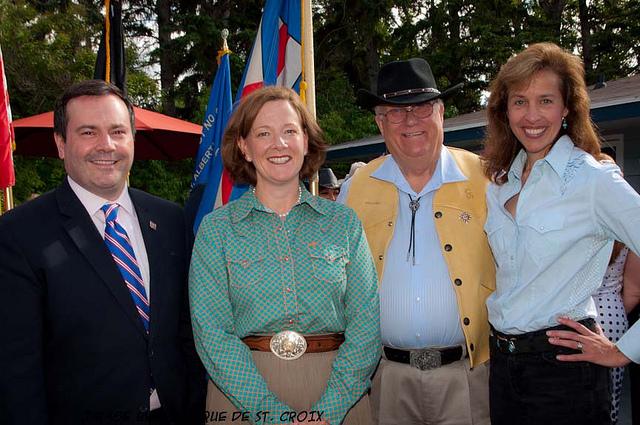Is this man's vest yellow?
Concise answer only. Yes. Are there an equal number of neckties and bolos?
Write a very short answer. Yes. How many flags are in the background?
Answer briefly. 4. 